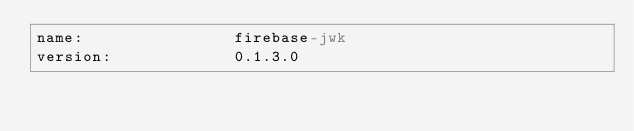Convert code to text. <code><loc_0><loc_0><loc_500><loc_500><_YAML_>name:                firebase-jwk
version:             0.1.3.0</code> 